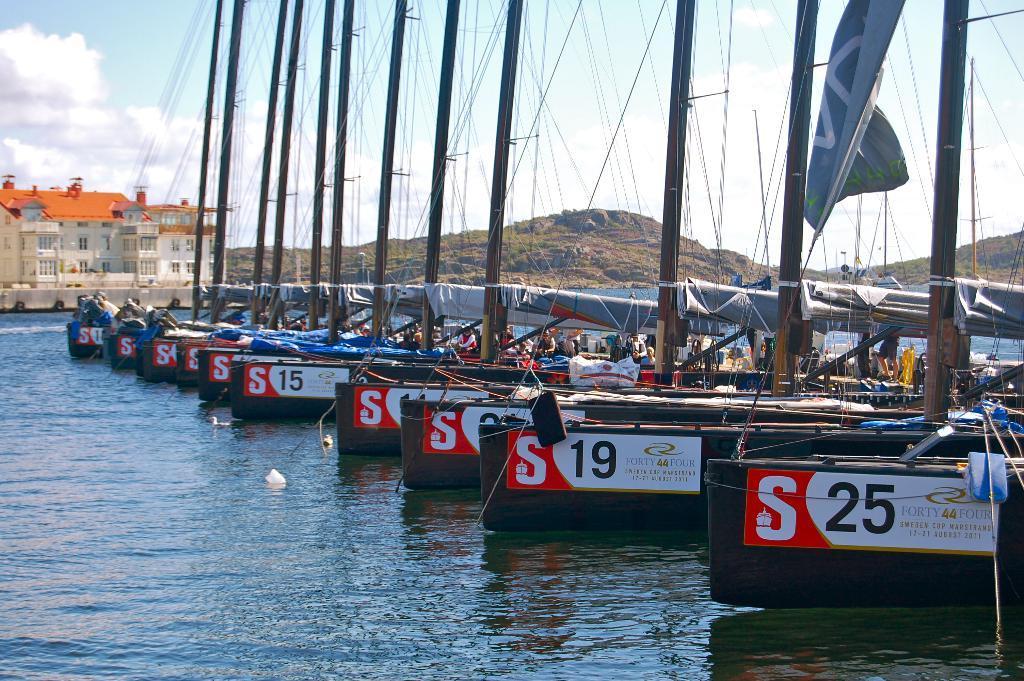In one or two sentences, can you explain what this image depicts? In this image, we can see some water with objects floating on it. We can also see some poles with wires. There are a few tents, people. We can also see a building and some hills. We can also see the sky with clouds. 